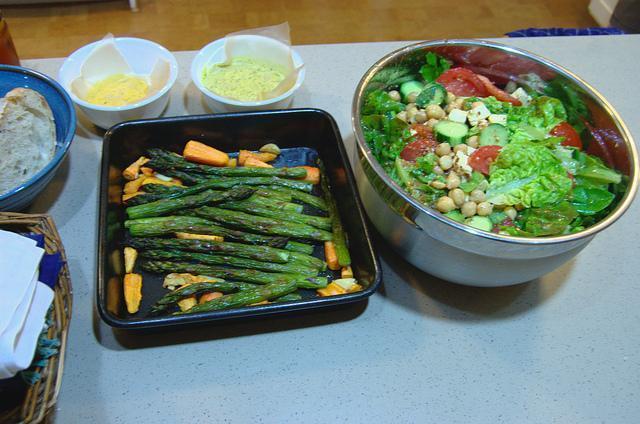How many bowls are in this picture?
Give a very brief answer. 4. How many bowls are there?
Give a very brief answer. 4. How many levels on this bus are red?
Give a very brief answer. 0. 